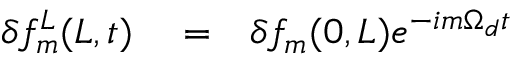Convert formula to latex. <formula><loc_0><loc_0><loc_500><loc_500>\begin{array} { r l r } { \delta f _ { m } ^ { L } ( L , t ) } & = } & { \delta f _ { m } ( 0 , L ) e ^ { - i m \Omega _ { d } t } } \end{array}</formula> 